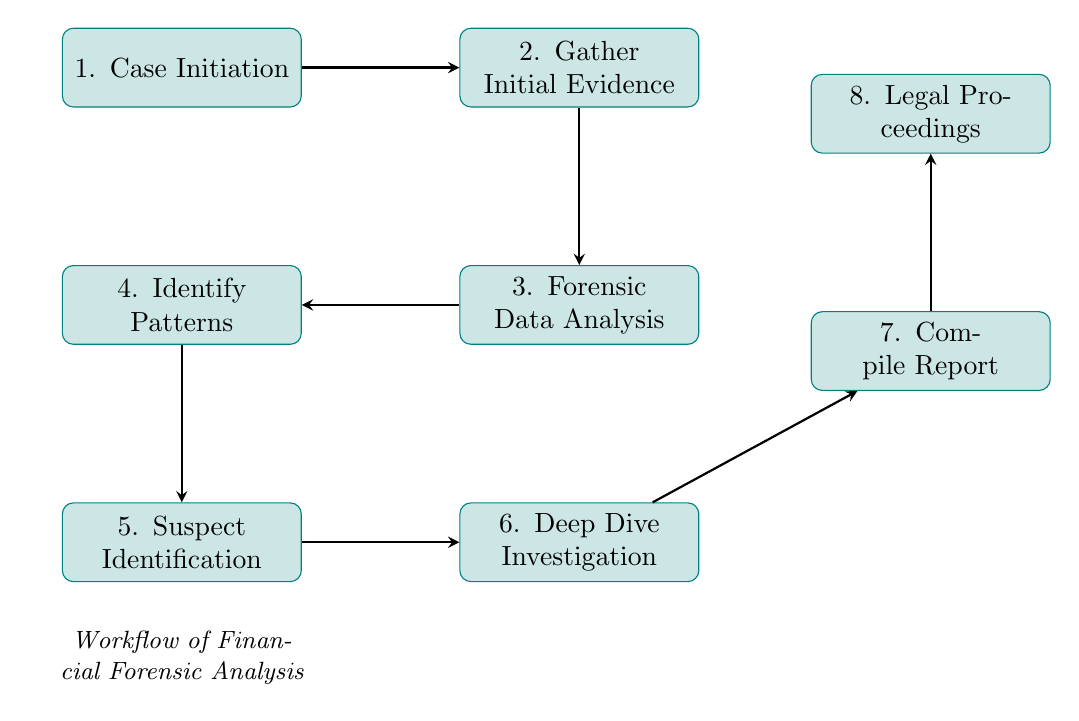What is the first step in the workflow? The first step in the workflow, as per the diagram, is "Case Initiation," which is the point where the white-collar crime case is identified.
Answer: Case Initiation How many nodes are in the diagram? The diagram consists of eight nodes, each representing a specific step in the financial forensic analysis workflow.
Answer: Eight What follows "Gather Initial Evidence"? Following "Gather Initial Evidence," the next step in the workflow is "Forensic Data Analysis," where financial data is analyzed for anomalies.
Answer: Forensic Data Analysis Which node is directly connected to "Identify Patterns"? The node directly connected to "Identify Patterns" is "Suspect Identification," indicating that identifying patterns leads to pinpointing suspects.
Answer: Suspect Identification What is the ultimate outcome of the workflow? The ultimate outcome of the workflow, as indicated at the end of the flow, is "Legal Proceedings," which represents the usage of findings to support legal actions.
Answer: Legal Proceedings In which step is evidence documented? Evidence is documented in the "Compile Report" step, where findings, analysis, and conclusions are gathered into a comprehensive report.
Answer: Compile Report How many arrows are in the flow chart? There are seven arrows in the flow chart, each representing the transition from one step to the next within the workflow.
Answer: Seven What step comes immediately before "Deep Dive Investigation"? The step that comes immediately before "Deep Dive Investigation" is "Suspect Identification," indicating that identifying suspects leads to a more detailed investigation.
Answer: Suspect Identification What type of software is used in "Forensic Data Analysis"? The "Forensic Data Analysis" step utilizes software tools like ACL Analytics and IDEA for analyzing financial data.
Answer: ACL Analytics and IDEA 